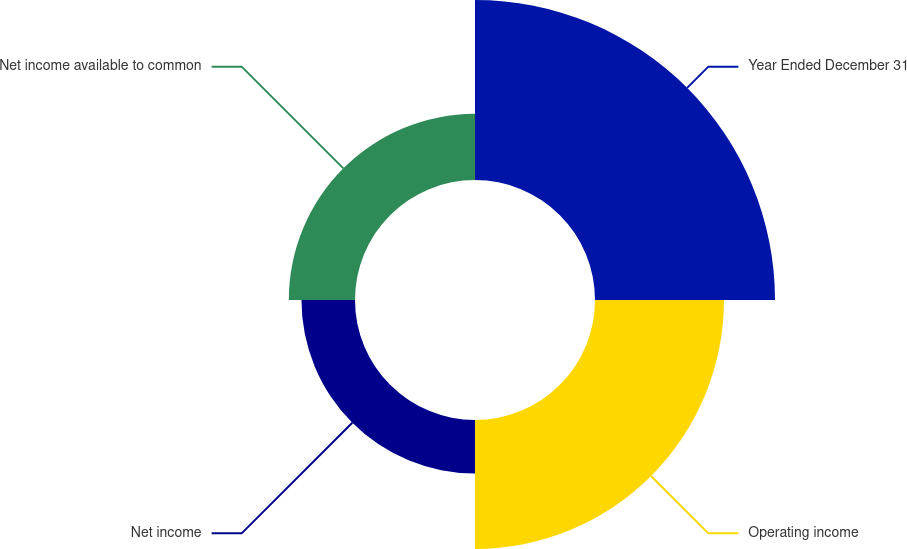<chart> <loc_0><loc_0><loc_500><loc_500><pie_chart><fcel>Year Ended December 31<fcel>Operating income<fcel>Net income<fcel>Net income available to common<nl><fcel>41.99%<fcel>30.09%<fcel>12.49%<fcel>15.44%<nl></chart> 